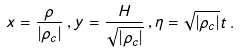Convert formula to latex. <formula><loc_0><loc_0><loc_500><loc_500>x = \frac { \rho } { | \rho _ { c } | } \, , y = \frac { H } { \sqrt { | \rho _ { c } | } } \, , \eta = \sqrt { | \rho _ { c } | } t \, .</formula> 